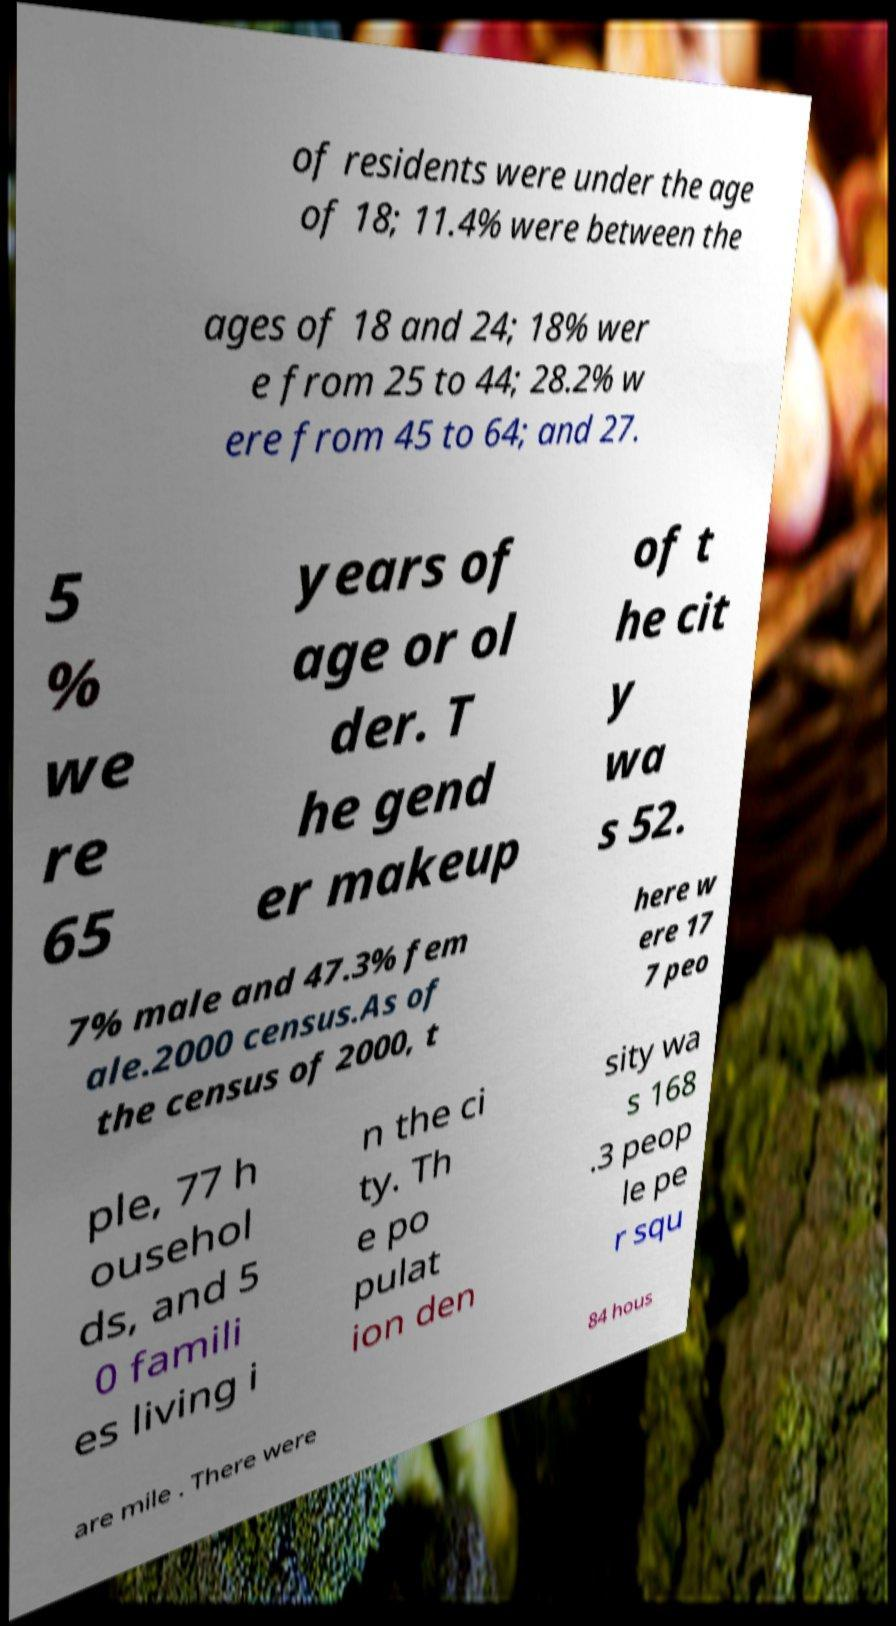What messages or text are displayed in this image? I need them in a readable, typed format. of residents were under the age of 18; 11.4% were between the ages of 18 and 24; 18% wer e from 25 to 44; 28.2% w ere from 45 to 64; and 27. 5 % we re 65 years of age or ol der. T he gend er makeup of t he cit y wa s 52. 7% male and 47.3% fem ale.2000 census.As of the census of 2000, t here w ere 17 7 peo ple, 77 h ousehol ds, and 5 0 famili es living i n the ci ty. Th e po pulat ion den sity wa s 168 .3 peop le pe r squ are mile . There were 84 hous 